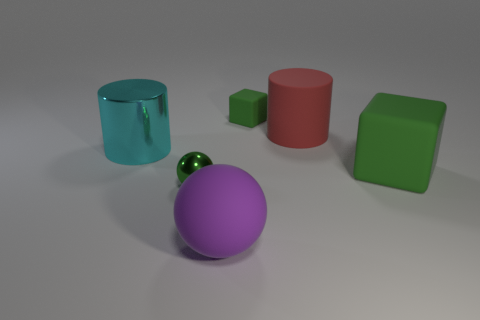What number of large purple shiny spheres are there?
Offer a terse response. 0. Does the green object left of the tiny block have the same material as the large purple sphere?
Make the answer very short. No. Are there any other things that are the same material as the big purple object?
Your response must be concise. Yes. How many tiny matte cubes are to the right of the cylinder that is on the left side of the tiny object on the left side of the purple object?
Ensure brevity in your answer.  1. The green shiny sphere has what size?
Your answer should be very brief. Small. Is the color of the tiny sphere the same as the rubber sphere?
Keep it short and to the point. No. There is a matte thing that is right of the big matte cylinder; how big is it?
Give a very brief answer. Large. There is a cylinder to the left of the large red rubber thing; is it the same color as the small object left of the matte ball?
Ensure brevity in your answer.  No. Are there an equal number of green metallic balls that are behind the cyan object and small things on the right side of the big purple matte sphere?
Make the answer very short. No. Do the cube to the left of the red cylinder and the cube in front of the cyan shiny cylinder have the same material?
Make the answer very short. Yes. 